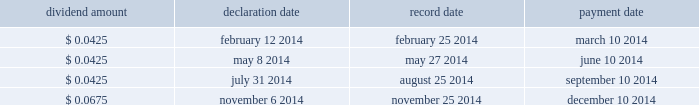Overview we finance our operations and capital expenditures through a combination of internally generated cash from operations and from borrowings under our senior secured asset-based revolving credit facility .
We believe that our current sources of funds will be sufficient to fund our cash operating requirements for the next year .
In addition , we believe that , in spite of the uncertainty of future macroeconomic conditions , we have adequate sources of liquidity and funding available to meet our longer-term needs .
However , there are a number of factors that may negatively impact our available sources of funds .
The amount of cash generated from operations will be dependent upon factors such as the successful execution of our business plan and general economic conditions .
Long-term debt activities during the year ended december 31 , 2014 , we had significant debt refinancings .
In connection with these refinancings , we recorded a loss on extinguishment of long-term debt of $ 90.7 million in our consolidated statement of operations for the year ended december 31 , 2014 .
See note 7 to the accompanying audited consolidated financial statements included elsewhere in this report for additional details .
Share repurchase program on november 6 , 2014 , we announced that our board of directors approved a $ 500 million share repurchase program effective immediately under which we may repurchase shares of our common stock in the open market or through privately negotiated transactions , depending on share price , market conditions and other factors .
The share repurchase program does not obligate us to repurchase any dollar amount or number of shares , and repurchases may be commenced or suspended from time to time without prior notice .
As of the date of this filing , no shares have been repurchased under the share repurchase program .
Dividends a summary of 2014 dividend activity for our common stock is shown below: .
On february 10 , 2015 , we announced that our board of directors declared a quarterly cash dividend on our common stock of $ 0.0675 per share .
The dividend will be paid on march 10 , 2015 to all stockholders of record as of the close of business on february 25 , 2015 .
The payment of any future dividends will be at the discretion of our board of directors and will depend upon our results of operations , financial condition , business prospects , capital requirements , contractual restrictions , any potential indebtedness we may incur , restrictions imposed by applicable law , tax considerations and other factors that our board of directors deems relevant .
In addition , our ability to pay dividends on our common stock will be limited by restrictions on our ability to pay dividends or make distributions to our stockholders and on the ability of our subsidiaries to pay dividends or make distributions to us , in each case , under the terms of our current and any future agreements governing our indebtedness .
Table of contents .
If you held 1000 shares on may 30 , 2014 , how much would you receive in dividends? 
Computations: (0.0425 * 1000)
Answer: 42.5. 